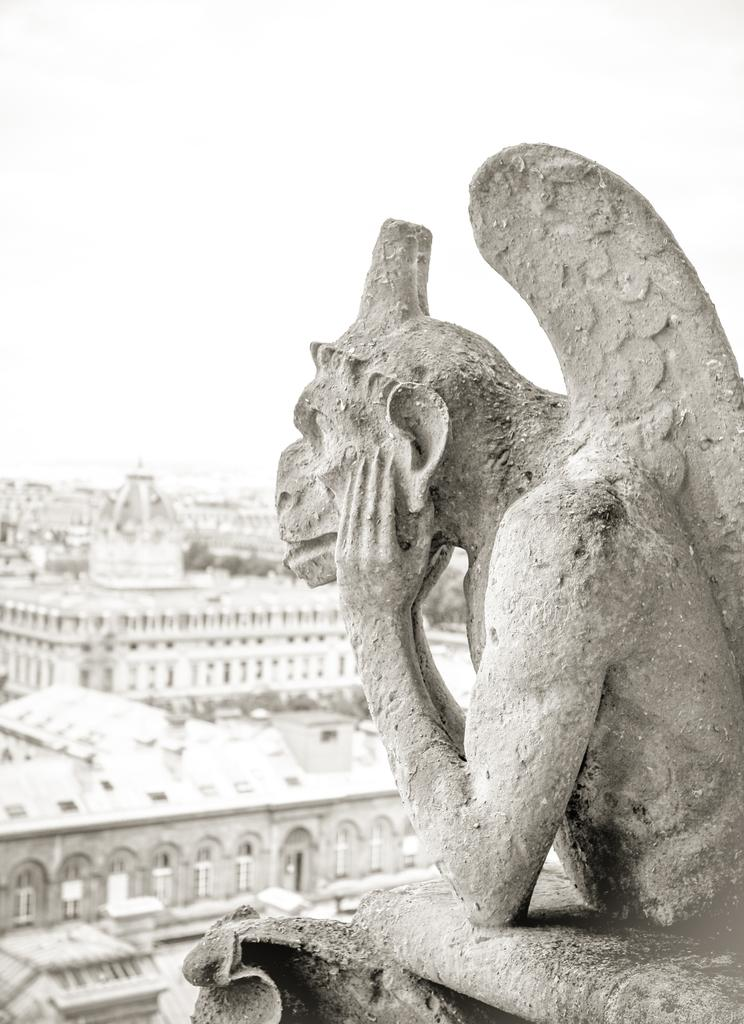What is the main subject in the foreground of the image? There is a statue in the foreground of the image. What can be seen in the background of the image? There are buildings and trees in the background of the image. What is visible at the top of the image? The sky is visible at the top of the image. Can you see the statue breathing in the image? The statue is not a living being and therefore cannot breathe. The image only shows a statue, buildings, trees, and the sky. 